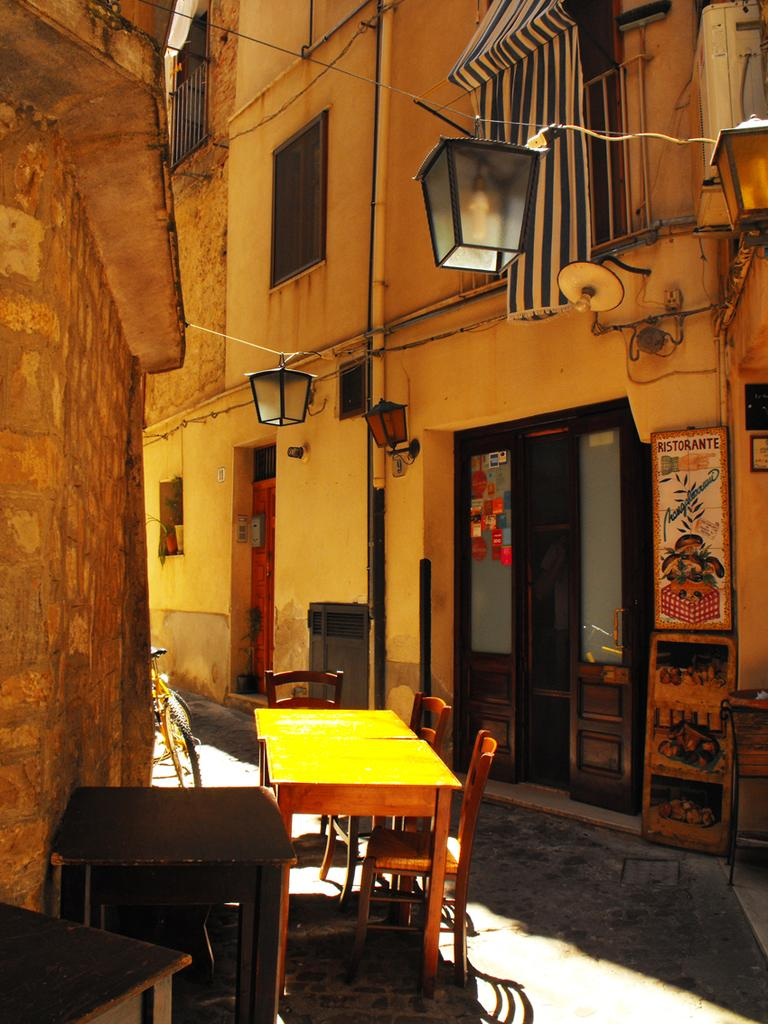What type of furniture is present in the image? There are tables and chairs in the image. What mode of transportation can be seen in the image? There are bicycles in the image. What type of illumination is present in the image? There are lights in the image. What type of decoration is present in the image? There is a poster in the image. What type of material is present in the image? There is wire in the image. What type of structures are present in the image? There are buildings in the image. Can you tell me how many giraffes are depicted on the poster in the image? There are no giraffes depicted on the poster or in the image; it does not feature any animals. What type of kitty is sitting on the bicycle in the image? There is no kitty present in the image, and therefore no such activity can be observed. 